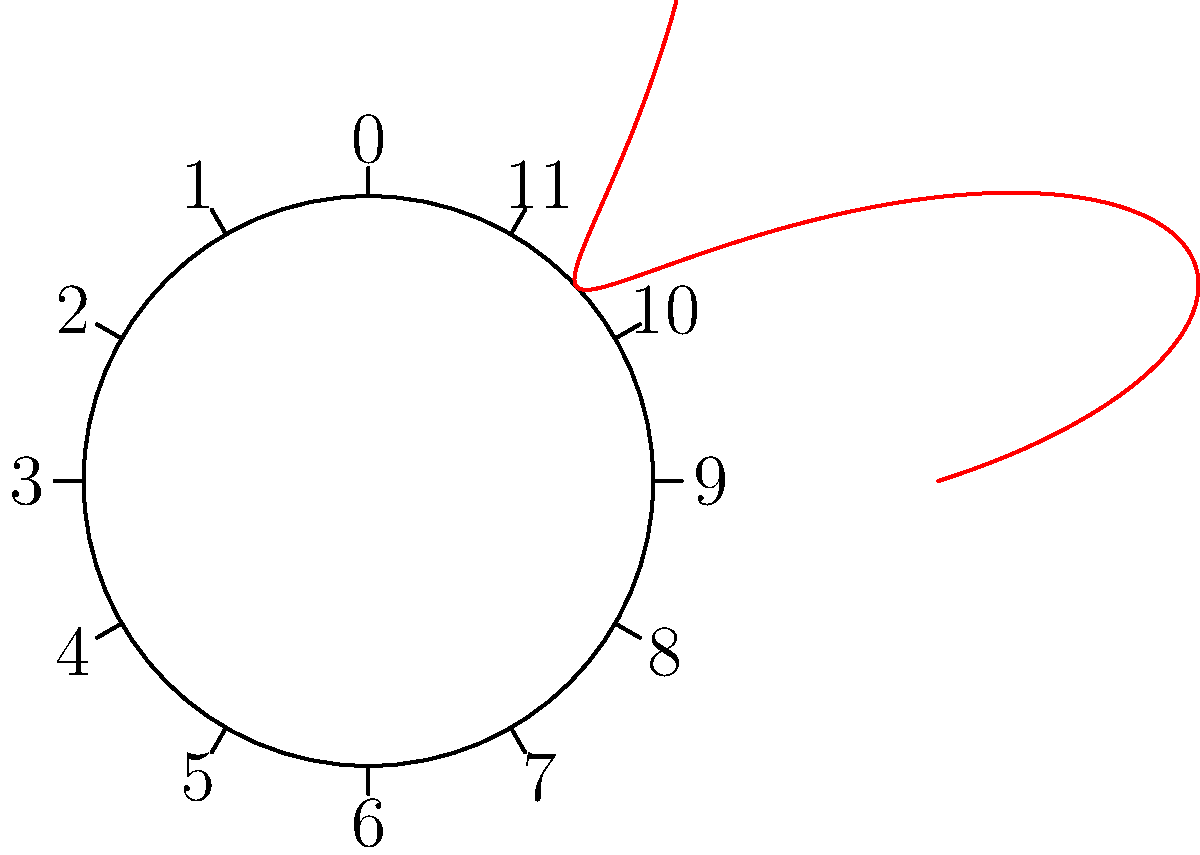As a farmer who appreciates the importance of health check-ups, you understand the value of monitoring crop growth throughout the year. The polar graph above represents the growth rate of your crops over a 12-month period, where the distance from the center indicates the growth rate, and the angle represents the month (0° is January, 30° is February, and so on). In which month does the crop show the highest growth rate? To determine the month with the highest growth rate, we need to follow these steps:

1. Observe that the graph is plotted in polar coordinates, where the angle represents the month and the radius represents the growth rate.
2. The circle is divided into 12 equal parts, each representing a month (30° per month).
3. January starts at 0°, February at 30°, March at 60°, and so on.
4. The red curve shows the variation in growth rate throughout the year.
5. The point on the curve farthest from the center represents the highest growth rate.
6. By inspection, we can see that this point occurs between the 6 and 7 marks on the circle.
7. The 6 mark represents July (6 * 30° = 180°), and the 7 mark represents August (7 * 30° = 210°).
8. The highest point is closer to the 7 mark, indicating that the maximum growth rate occurs in August.

This analysis shows that the crop growth rate peaks in August, which aligns with the typical harvest season for many crops.
Answer: August 